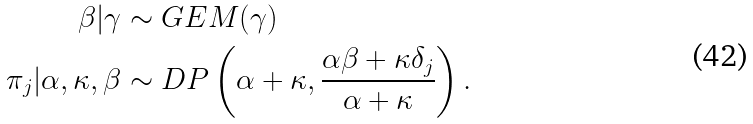Convert formula to latex. <formula><loc_0><loc_0><loc_500><loc_500>\beta | \gamma & \sim G E M ( \gamma ) \\ \pi _ { j } | \alpha , \kappa , \beta & \sim D P \left ( \alpha + \kappa , \frac { \alpha \beta + \kappa \delta _ { j } } { \alpha + \kappa } \right ) .</formula> 